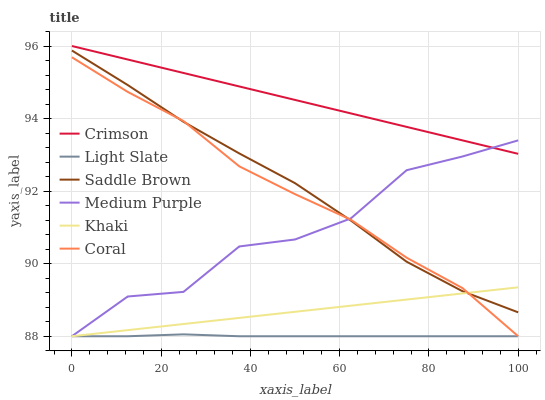Does Light Slate have the minimum area under the curve?
Answer yes or no. Yes. Does Crimson have the maximum area under the curve?
Answer yes or no. Yes. Does Coral have the minimum area under the curve?
Answer yes or no. No. Does Coral have the maximum area under the curve?
Answer yes or no. No. Is Crimson the smoothest?
Answer yes or no. Yes. Is Medium Purple the roughest?
Answer yes or no. Yes. Is Light Slate the smoothest?
Answer yes or no. No. Is Light Slate the roughest?
Answer yes or no. No. Does Khaki have the lowest value?
Answer yes or no. Yes. Does Crimson have the lowest value?
Answer yes or no. No. Does Crimson have the highest value?
Answer yes or no. Yes. Does Coral have the highest value?
Answer yes or no. No. Is Saddle Brown less than Crimson?
Answer yes or no. Yes. Is Saddle Brown greater than Light Slate?
Answer yes or no. Yes. Does Light Slate intersect Coral?
Answer yes or no. Yes. Is Light Slate less than Coral?
Answer yes or no. No. Is Light Slate greater than Coral?
Answer yes or no. No. Does Saddle Brown intersect Crimson?
Answer yes or no. No. 